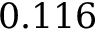<formula> <loc_0><loc_0><loc_500><loc_500>0 . 1 1 6</formula> 